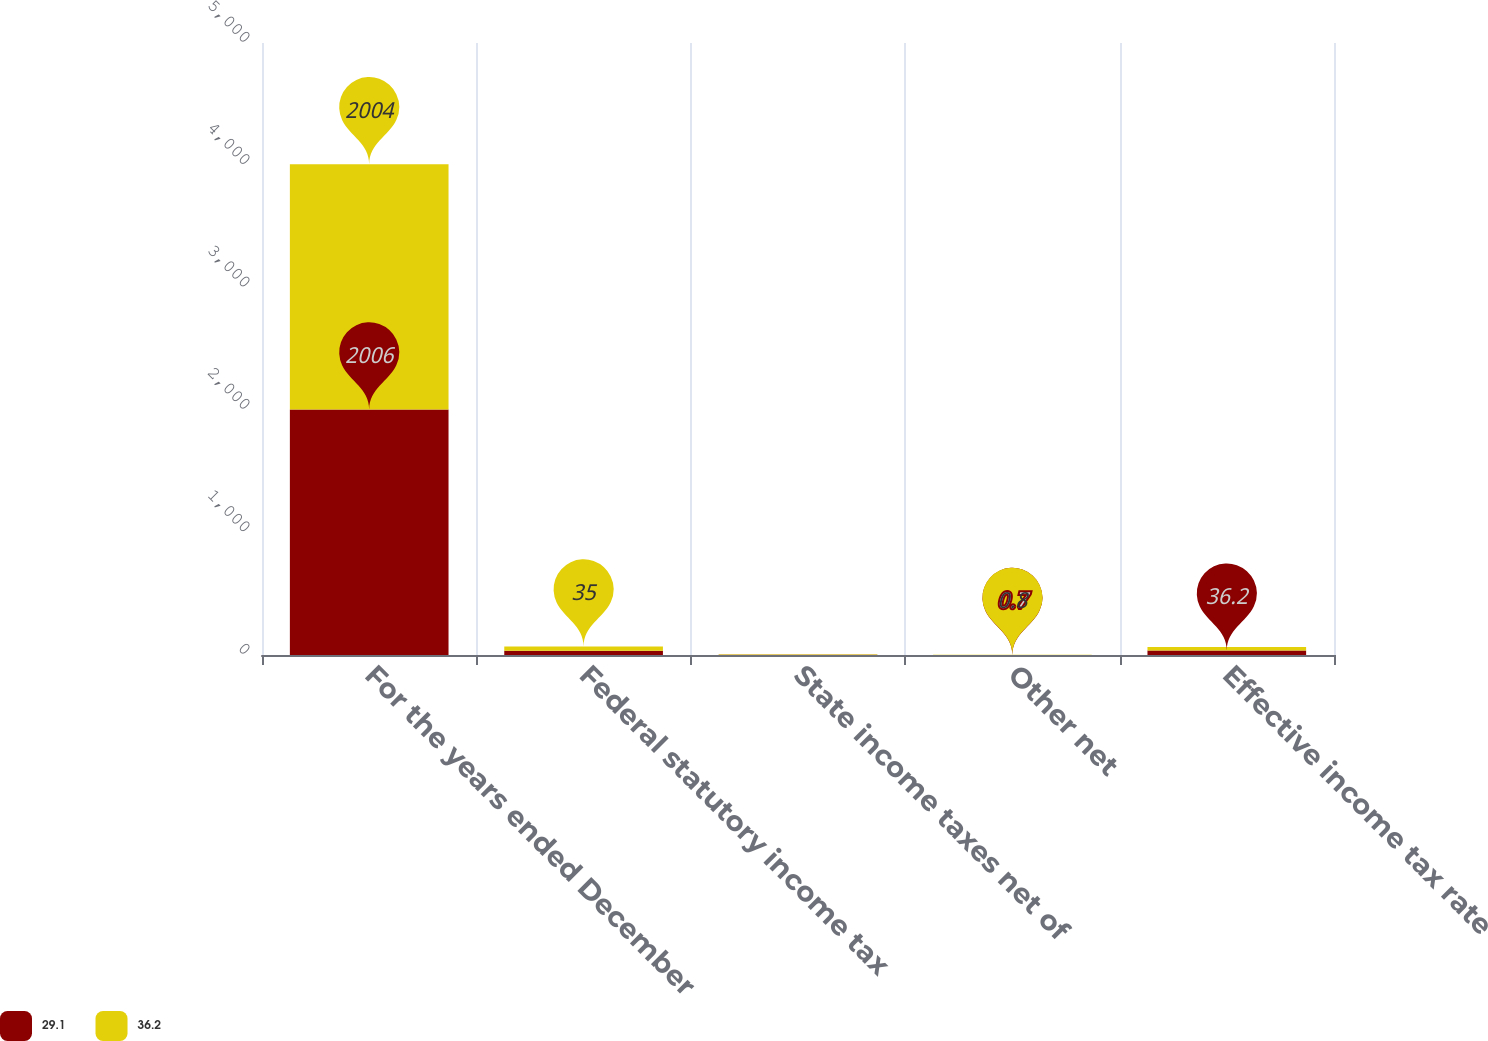Convert chart to OTSL. <chart><loc_0><loc_0><loc_500><loc_500><stacked_bar_chart><ecel><fcel>For the years ended December<fcel>Federal statutory income tax<fcel>State income taxes net of<fcel>Other net<fcel>Effective income tax rate<nl><fcel>29.1<fcel>2006<fcel>35<fcel>2.8<fcel>0.7<fcel>36.2<nl><fcel>36.2<fcel>2004<fcel>35<fcel>2.6<fcel>0.8<fcel>29.1<nl></chart> 